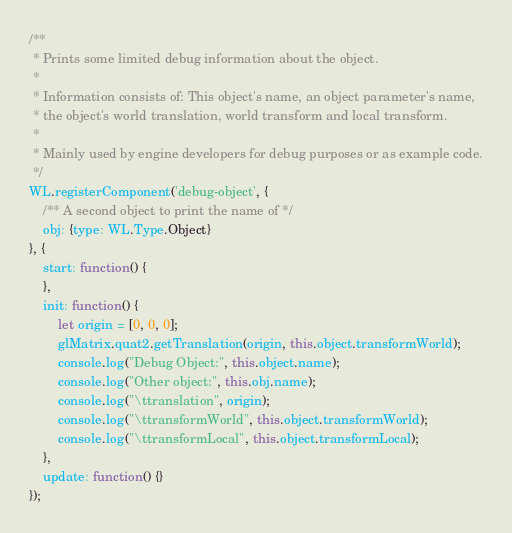Convert code to text. <code><loc_0><loc_0><loc_500><loc_500><_JavaScript_>/**
 * Prints some limited debug information about the object.
 *
 * Information consists of: This object's name, an object parameter's name,
 * the object's world translation, world transform and local transform.
 *
 * Mainly used by engine developers for debug purposes or as example code.
 */
WL.registerComponent('debug-object', {
    /** A second object to print the name of */
    obj: {type: WL.Type.Object}
}, {
    start: function() {
    },
    init: function() {
        let origin = [0, 0, 0];
        glMatrix.quat2.getTranslation(origin, this.object.transformWorld);
        console.log("Debug Object:", this.object.name);
        console.log("Other object:", this.obj.name);
        console.log("\ttranslation", origin);
        console.log("\ttransformWorld", this.object.transformWorld);
        console.log("\ttransformLocal", this.object.transformLocal);
    },
    update: function() {}
});
</code> 